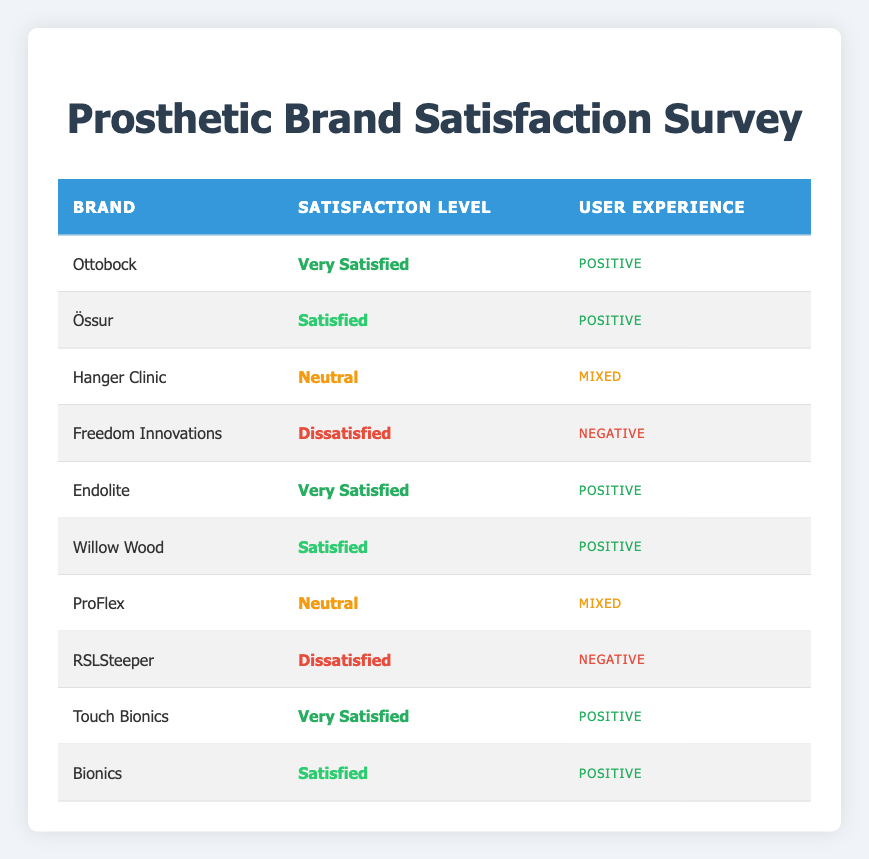What is the satisfaction level of the brand Ottobock? The table shows that the brand Ottobock has a satisfaction level of "Very Satisfied," which is directly referenced in the corresponding row.
Answer: Very Satisfied How many brands have a satisfaction level of "Dissatisfied"? Upon reviewing the table, Freedom Innovations and RSLSteeper both show a satisfaction level of "Dissatisfied," giving a total count of 2 brands.
Answer: 2 Which brand has the highest satisfaction level, and what is that level? The brands with the highest satisfaction level shown in the table are Ottobock, Endolite, and Touch Bionics, all listed as "Very Satisfied." There isn't a single brand that stands out above the others in satisfaction.
Answer: Ottobock, Endolite, Touch Bionics - Very Satisfied What percentage of brands reported a "Positive" user experience? There are 5 brands listed with a "Positive" user experience: Ottobock, Össur, Endolite, Willow Wood, and Bionics. Since there are 10 brands total, the percentage is (5/10) * 100 = 50%.
Answer: 50% Is it true that all "Very Satisfied" users also reported a "Positive" user experience? Yes, by examining the table, all the brands that received a "Very Satisfied" rating (Ottobock, Endolite, and Touch Bionics) also have a corresponding "Positive" user experience, confirming the statement is true.
Answer: Yes Which brand has a "Neutral" satisfaction level with a "Mixed" user experience? The brand ProFlex is noted in the table with a "Neutral" satisfaction level and a "Mixed" user experience, answering the question directly.
Answer: ProFlex How many brands have a satisfaction level of "Satisfied" and also report a "Positive" user experience? The brands with a satisfaction level of "Satisfied" that also report a "Positive" user experience are Össur, Willow Wood, and Bionics. This totals 3 brands.
Answer: 3 What is the difference in the number of brands that are "Dissatisfied" versus those that are "Very Satisfied"? There are 2 brands that are "Dissatisfied" (Freedom Innovations and RSLSteeper) and 3 brands that are "Very Satisfied" (Ottobock, Endolite, Touch Bionics). The difference is 3 - 2 = 1 brand more for "Very Satisfied."
Answer: 1 Are there any brands that received a "Neutral" satisfaction level? Yes, the table highlights Hanger Clinic and ProFlex as brands that have a "Neutral" satisfaction level, confirming the presence of such brands.
Answer: Yes 